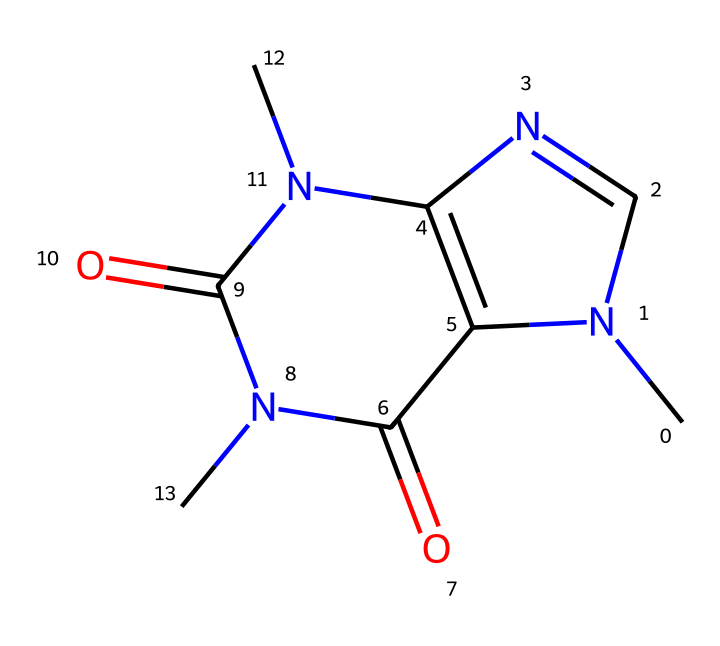What is the name of this chemical? The structure corresponds to caffeine, a well-known stimulant found in coffee and tea.
Answer: caffeine How many nitrogen atoms are in the structure? By examining the SMILES representation, we can count three nitrogen atoms present in the structure.
Answer: three What are the functional groups present? The chemical contains two carbonyl groups (C=O) and several nitrogen atoms, indicating it belongs to the class of substituted xanthines.
Answer: carbonyl groups and nitrogen Is this compound a stimulant? Caffeine is recognized for its stimulant properties, which enhance alertness and athletic performance.
Answer: yes What is the molecular formula of this substance? By understanding the structure and counting the atoms, the molecular formula can be derived as C8H10N4O2.
Answer: C8H10N4O2 How does this chemical enhance athletic performance? Caffeine enhances performance by increasing adrenaline levels and improving endurance through its stimulant effects on the central nervous system.
Answer: increases adrenaline and improves endurance What is the general category of this compound regarding its use? Caffeine is categorized as a central nervous system stimulant, commonly used to enhance athletic performance and alertness.
Answer: central nervous system stimulant 